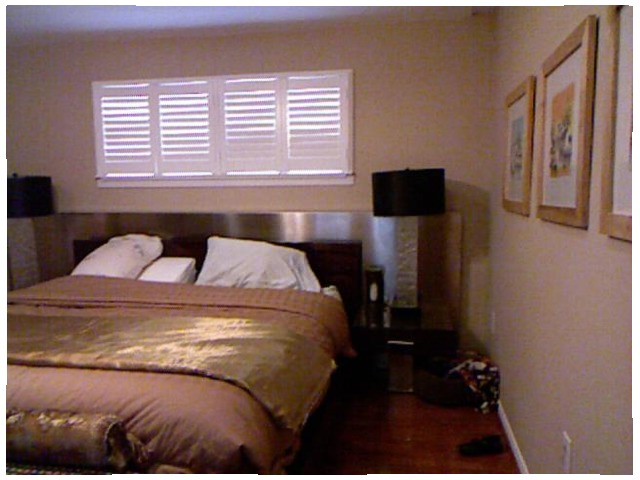<image>
Is there a shoe under the outlet? Yes. The shoe is positioned underneath the outlet, with the outlet above it in the vertical space. Where is the pillow in relation to the bed? Is it on the bed? Yes. Looking at the image, I can see the pillow is positioned on top of the bed, with the bed providing support. 